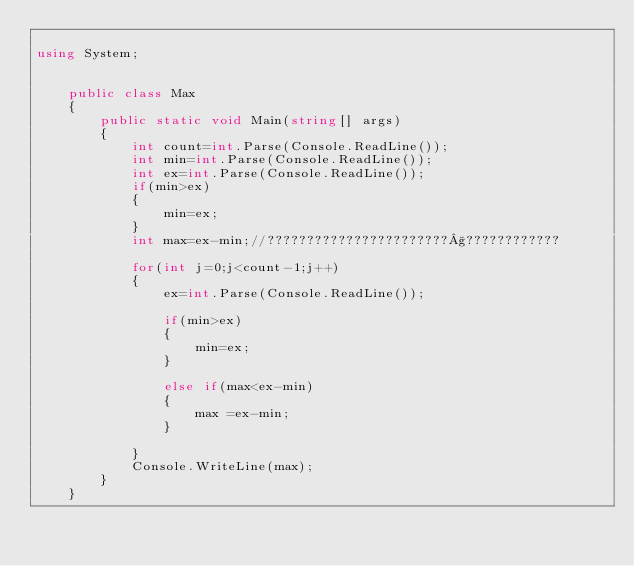<code> <loc_0><loc_0><loc_500><loc_500><_C#_>
using System;


	public class Max
	{
		public static void Main(string[] args)
		{
			int count=int.Parse(Console.ReadLine());			
			int min=int.Parse(Console.ReadLine());
			int ex=int.Parse(Console.ReadLine());
			if(min>ex)
			{
				min=ex;
			}
			int max=ex-min;//???????????????????????§????????????
			
			for(int j=0;j<count-1;j++)
			{
				ex=int.Parse(Console.ReadLine());
				
				if(min>ex)
				{
					min=ex;
				}
				
			    else if(max<ex-min)
				{
					max =ex-min;
				}
				
			}
			Console.WriteLine(max);
		}
	}</code> 